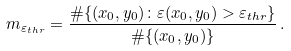Convert formula to latex. <formula><loc_0><loc_0><loc_500><loc_500>m _ { \varepsilon _ { t h r } } = \frac { \# \{ ( x _ { 0 } , y _ { 0 } ) \colon \varepsilon ( x _ { 0 } , y _ { 0 } ) > \varepsilon _ { t h r } \} } { \# \{ ( x _ { 0 } , y _ { 0 } ) \} } \, .</formula> 